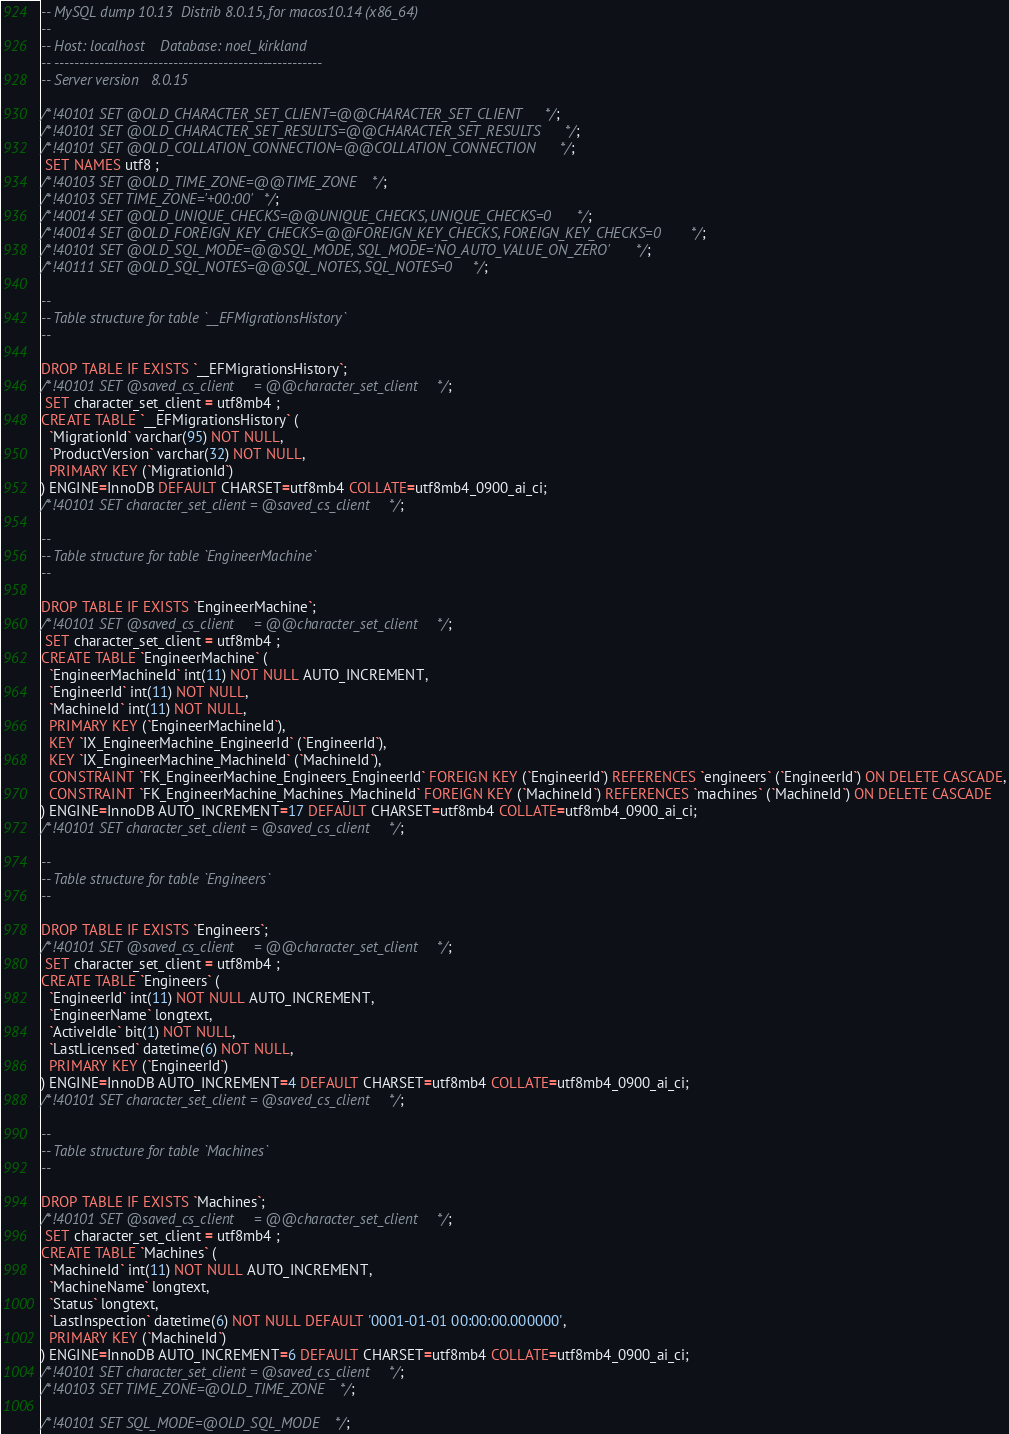<code> <loc_0><loc_0><loc_500><loc_500><_SQL_>-- MySQL dump 10.13  Distrib 8.0.15, for macos10.14 (x86_64)
--
-- Host: localhost    Database: noel_kirkland
-- ------------------------------------------------------
-- Server version	8.0.15

/*!40101 SET @OLD_CHARACTER_SET_CLIENT=@@CHARACTER_SET_CLIENT */;
/*!40101 SET @OLD_CHARACTER_SET_RESULTS=@@CHARACTER_SET_RESULTS */;
/*!40101 SET @OLD_COLLATION_CONNECTION=@@COLLATION_CONNECTION */;
 SET NAMES utf8 ;
/*!40103 SET @OLD_TIME_ZONE=@@TIME_ZONE */;
/*!40103 SET TIME_ZONE='+00:00' */;
/*!40014 SET @OLD_UNIQUE_CHECKS=@@UNIQUE_CHECKS, UNIQUE_CHECKS=0 */;
/*!40014 SET @OLD_FOREIGN_KEY_CHECKS=@@FOREIGN_KEY_CHECKS, FOREIGN_KEY_CHECKS=0 */;
/*!40101 SET @OLD_SQL_MODE=@@SQL_MODE, SQL_MODE='NO_AUTO_VALUE_ON_ZERO' */;
/*!40111 SET @OLD_SQL_NOTES=@@SQL_NOTES, SQL_NOTES=0 */;

--
-- Table structure for table `__EFMigrationsHistory`
--

DROP TABLE IF EXISTS `__EFMigrationsHistory`;
/*!40101 SET @saved_cs_client     = @@character_set_client */;
 SET character_set_client = utf8mb4 ;
CREATE TABLE `__EFMigrationsHistory` (
  `MigrationId` varchar(95) NOT NULL,
  `ProductVersion` varchar(32) NOT NULL,
  PRIMARY KEY (`MigrationId`)
) ENGINE=InnoDB DEFAULT CHARSET=utf8mb4 COLLATE=utf8mb4_0900_ai_ci;
/*!40101 SET character_set_client = @saved_cs_client */;

--
-- Table structure for table `EngineerMachine`
--

DROP TABLE IF EXISTS `EngineerMachine`;
/*!40101 SET @saved_cs_client     = @@character_set_client */;
 SET character_set_client = utf8mb4 ;
CREATE TABLE `EngineerMachine` (
  `EngineerMachineId` int(11) NOT NULL AUTO_INCREMENT,
  `EngineerId` int(11) NOT NULL,
  `MachineId` int(11) NOT NULL,
  PRIMARY KEY (`EngineerMachineId`),
  KEY `IX_EngineerMachine_EngineerId` (`EngineerId`),
  KEY `IX_EngineerMachine_MachineId` (`MachineId`),
  CONSTRAINT `FK_EngineerMachine_Engineers_EngineerId` FOREIGN KEY (`EngineerId`) REFERENCES `engineers` (`EngineerId`) ON DELETE CASCADE,
  CONSTRAINT `FK_EngineerMachine_Machines_MachineId` FOREIGN KEY (`MachineId`) REFERENCES `machines` (`MachineId`) ON DELETE CASCADE
) ENGINE=InnoDB AUTO_INCREMENT=17 DEFAULT CHARSET=utf8mb4 COLLATE=utf8mb4_0900_ai_ci;
/*!40101 SET character_set_client = @saved_cs_client */;

--
-- Table structure for table `Engineers`
--

DROP TABLE IF EXISTS `Engineers`;
/*!40101 SET @saved_cs_client     = @@character_set_client */;
 SET character_set_client = utf8mb4 ;
CREATE TABLE `Engineers` (
  `EngineerId` int(11) NOT NULL AUTO_INCREMENT,
  `EngineerName` longtext,
  `ActiveIdle` bit(1) NOT NULL,
  `LastLicensed` datetime(6) NOT NULL,
  PRIMARY KEY (`EngineerId`)
) ENGINE=InnoDB AUTO_INCREMENT=4 DEFAULT CHARSET=utf8mb4 COLLATE=utf8mb4_0900_ai_ci;
/*!40101 SET character_set_client = @saved_cs_client */;

--
-- Table structure for table `Machines`
--

DROP TABLE IF EXISTS `Machines`;
/*!40101 SET @saved_cs_client     = @@character_set_client */;
 SET character_set_client = utf8mb4 ;
CREATE TABLE `Machines` (
  `MachineId` int(11) NOT NULL AUTO_INCREMENT,
  `MachineName` longtext,
  `Status` longtext,
  `LastInspection` datetime(6) NOT NULL DEFAULT '0001-01-01 00:00:00.000000',
  PRIMARY KEY (`MachineId`)
) ENGINE=InnoDB AUTO_INCREMENT=6 DEFAULT CHARSET=utf8mb4 COLLATE=utf8mb4_0900_ai_ci;
/*!40101 SET character_set_client = @saved_cs_client */;
/*!40103 SET TIME_ZONE=@OLD_TIME_ZONE */;

/*!40101 SET SQL_MODE=@OLD_SQL_MODE */;</code> 